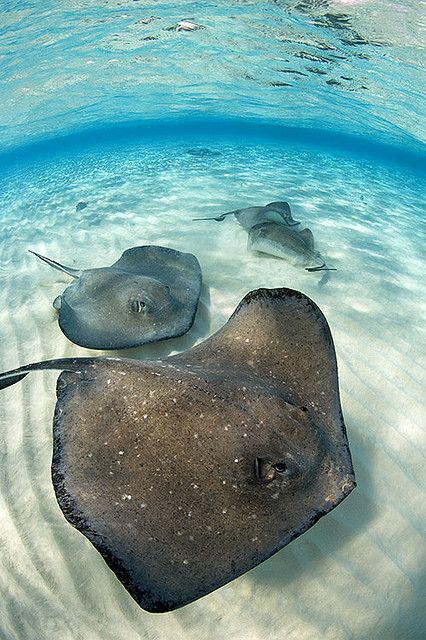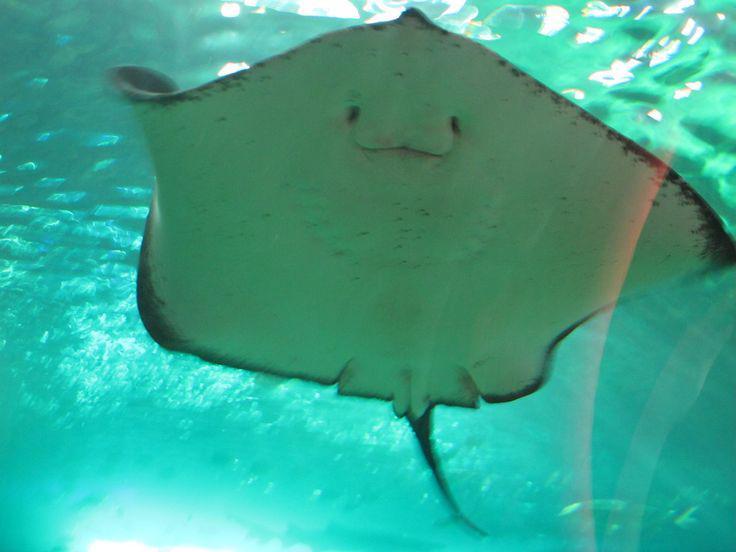The first image is the image on the left, the second image is the image on the right. Evaluate the accuracy of this statement regarding the images: "One stingray with a spotted pattern is included in the right image.". Is it true? Answer yes or no. No. The first image is the image on the left, the second image is the image on the right. Given the left and right images, does the statement "One of the images contains exactly one stingray." hold true? Answer yes or no. Yes. 